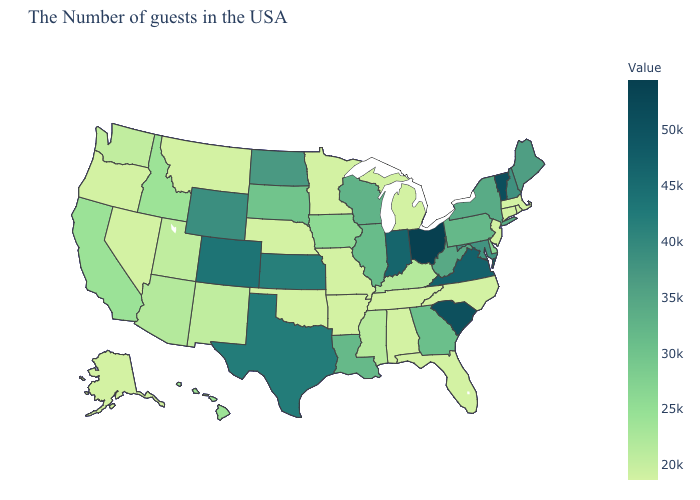Is the legend a continuous bar?
Keep it brief. Yes. Does Colorado have the highest value in the West?
Answer briefly. Yes. Does Connecticut have a lower value than North Dakota?
Write a very short answer. Yes. Among the states that border Washington , which have the lowest value?
Be succinct. Oregon. Does Utah have the highest value in the West?
Concise answer only. No. Does New Hampshire have the highest value in the USA?
Quick response, please. No. 